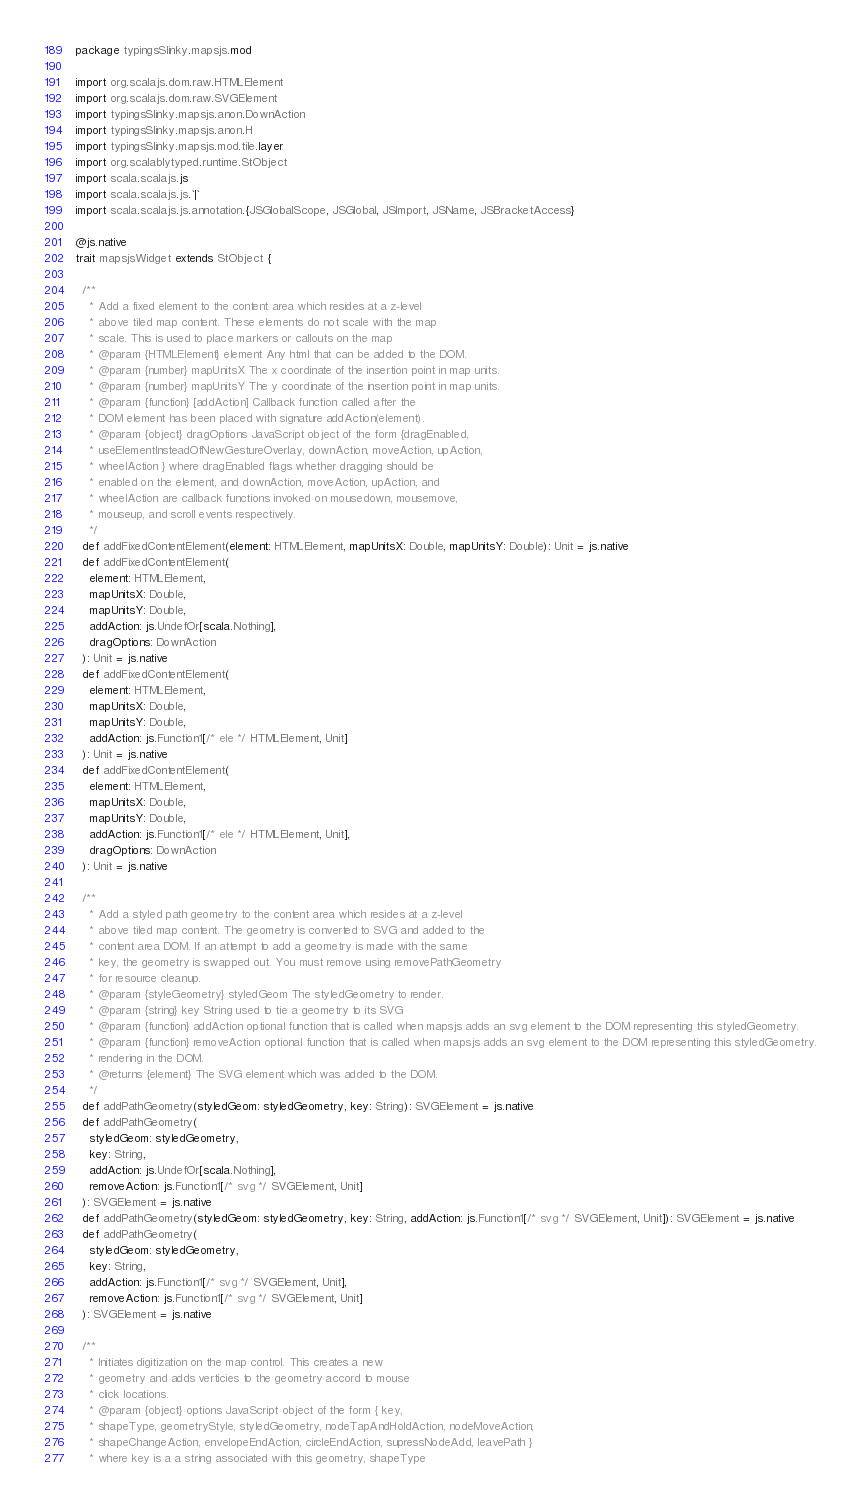<code> <loc_0><loc_0><loc_500><loc_500><_Scala_>package typingsSlinky.mapsjs.mod

import org.scalajs.dom.raw.HTMLElement
import org.scalajs.dom.raw.SVGElement
import typingsSlinky.mapsjs.anon.DownAction
import typingsSlinky.mapsjs.anon.H
import typingsSlinky.mapsjs.mod.tile.layer
import org.scalablytyped.runtime.StObject
import scala.scalajs.js
import scala.scalajs.js.`|`
import scala.scalajs.js.annotation.{JSGlobalScope, JSGlobal, JSImport, JSName, JSBracketAccess}

@js.native
trait mapsjsWidget extends StObject {
  
  /**
    * Add a fixed element to the content area which resides at a z-level 
    * above tiled map content. These elements do not scale with the map
    * scale. This is used to place markers or callouts on the map
    * @param {HTMLElement} element Any html that can be added to the DOM.
    * @param {number} mapUnitsX The x coordinate of the insertion point in map units.
    * @param {number} mapUnitsY The y coordinate of the insertion point in map units.
    * @param {function} [addAction] Callback function called after the 
    * DOM element has been placed with signature addAction(element).
    * @param {object} dragOptions JavaScript object of the form {dragEnabled,
    * useElementInsteadOfNewGestureOverlay, downAction, moveAction, upAction, 
    * wheelAction } where dragEnabled flags whether dragging should be
    * enabled on the element, and downAction, moveAction, upAction, and 
    * wheelAction are callback functions invoked on mousedown, mousemove,
    * mouseup, and scroll events respectively.
    */
  def addFixedContentElement(element: HTMLElement, mapUnitsX: Double, mapUnitsY: Double): Unit = js.native
  def addFixedContentElement(
    element: HTMLElement,
    mapUnitsX: Double,
    mapUnitsY: Double,
    addAction: js.UndefOr[scala.Nothing],
    dragOptions: DownAction
  ): Unit = js.native
  def addFixedContentElement(
    element: HTMLElement,
    mapUnitsX: Double,
    mapUnitsY: Double,
    addAction: js.Function1[/* ele */ HTMLElement, Unit]
  ): Unit = js.native
  def addFixedContentElement(
    element: HTMLElement,
    mapUnitsX: Double,
    mapUnitsY: Double,
    addAction: js.Function1[/* ele */ HTMLElement, Unit],
    dragOptions: DownAction
  ): Unit = js.native
  
  /**
    * Add a styled path geometry to the content area which resides at a z-level 
    * above tiled map content. The geometry is converted to SVG and added to the 
    * content area DOM. If an attempt to add a geometry is made with the same 
    * key, the geometry is swapped out. You must remove using removePathGeometry 
    * for resource cleanup.
    * @param {styleGeometry} styledGeom The styledGeometry to render.
    * @param {string} key String used to tie a geometry to its SVG
    * @param {function} addAction optional function that is called when mapsjs adds an svg element to the DOM representing this styledGeometry.
    * @param {function} removeAction optional function that is called when mapsjs adds an svg element to the DOM representing this styledGeometry.
    * rendering in the DOM.
    * @returns {element} The SVG element which was added to the DOM.
    */
  def addPathGeometry(styledGeom: styledGeometry, key: String): SVGElement = js.native
  def addPathGeometry(
    styledGeom: styledGeometry,
    key: String,
    addAction: js.UndefOr[scala.Nothing],
    removeAction: js.Function1[/* svg */ SVGElement, Unit]
  ): SVGElement = js.native
  def addPathGeometry(styledGeom: styledGeometry, key: String, addAction: js.Function1[/* svg */ SVGElement, Unit]): SVGElement = js.native
  def addPathGeometry(
    styledGeom: styledGeometry,
    key: String,
    addAction: js.Function1[/* svg */ SVGElement, Unit],
    removeAction: js.Function1[/* svg */ SVGElement, Unit]
  ): SVGElement = js.native
  
  /**
    * Initiates digitization on the map control. This creates a new
    * geometry and adds verticies to the geometry accord to mouse
    * click locations.
    * @param {object} options JavaScript object of the form { key,
    * shapeType, geometryStyle, styledGeometry, nodeTapAndHoldAction, nodeMoveAction,
    * shapeChangeAction, envelopeEndAction, circleEndAction, supressNodeAdd, leavePath }
    * where key is a a string associated with this geometry, shapeType</code> 